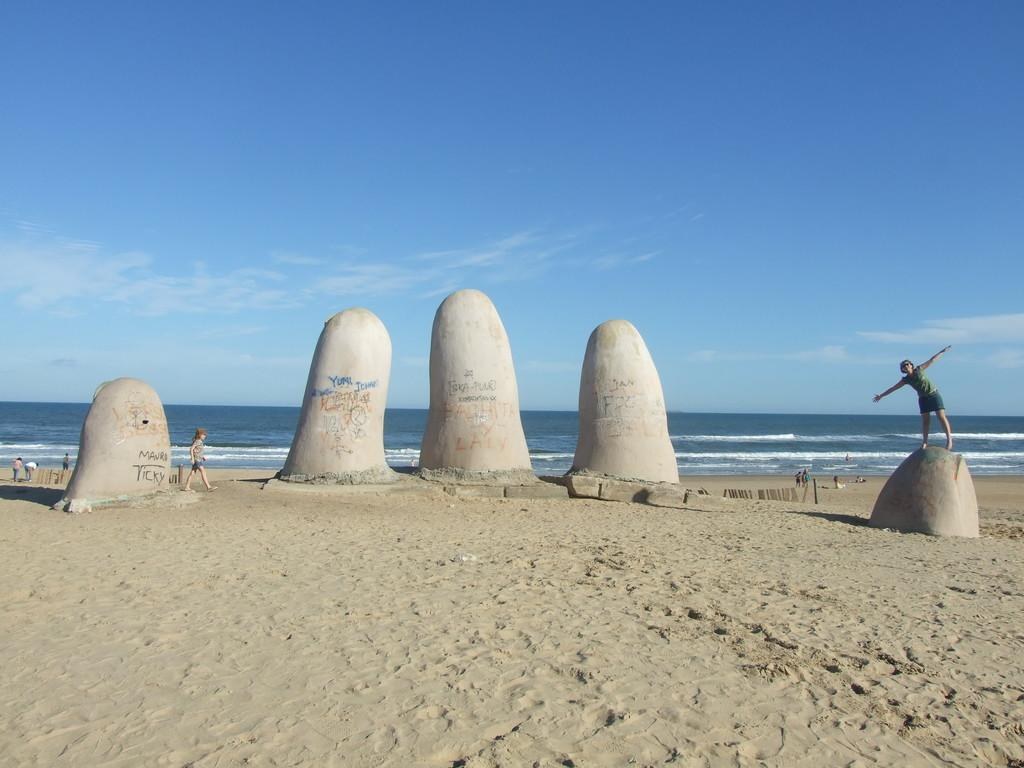What type of natural objects can be seen in the image? There are big stones in the image. What are the people in the image doing? The people are standing and walking in the image. What type of surface are the people walking on? The people are on sand. What can be seen in the background of the image? There is water visible in the background of the image. What is visible in the sky-wise in the image? There are clouds in the sky. What type of legal advice can be heard from the lawyer in the image? There is no lawyer present in the image, so no legal advice can be heard. 